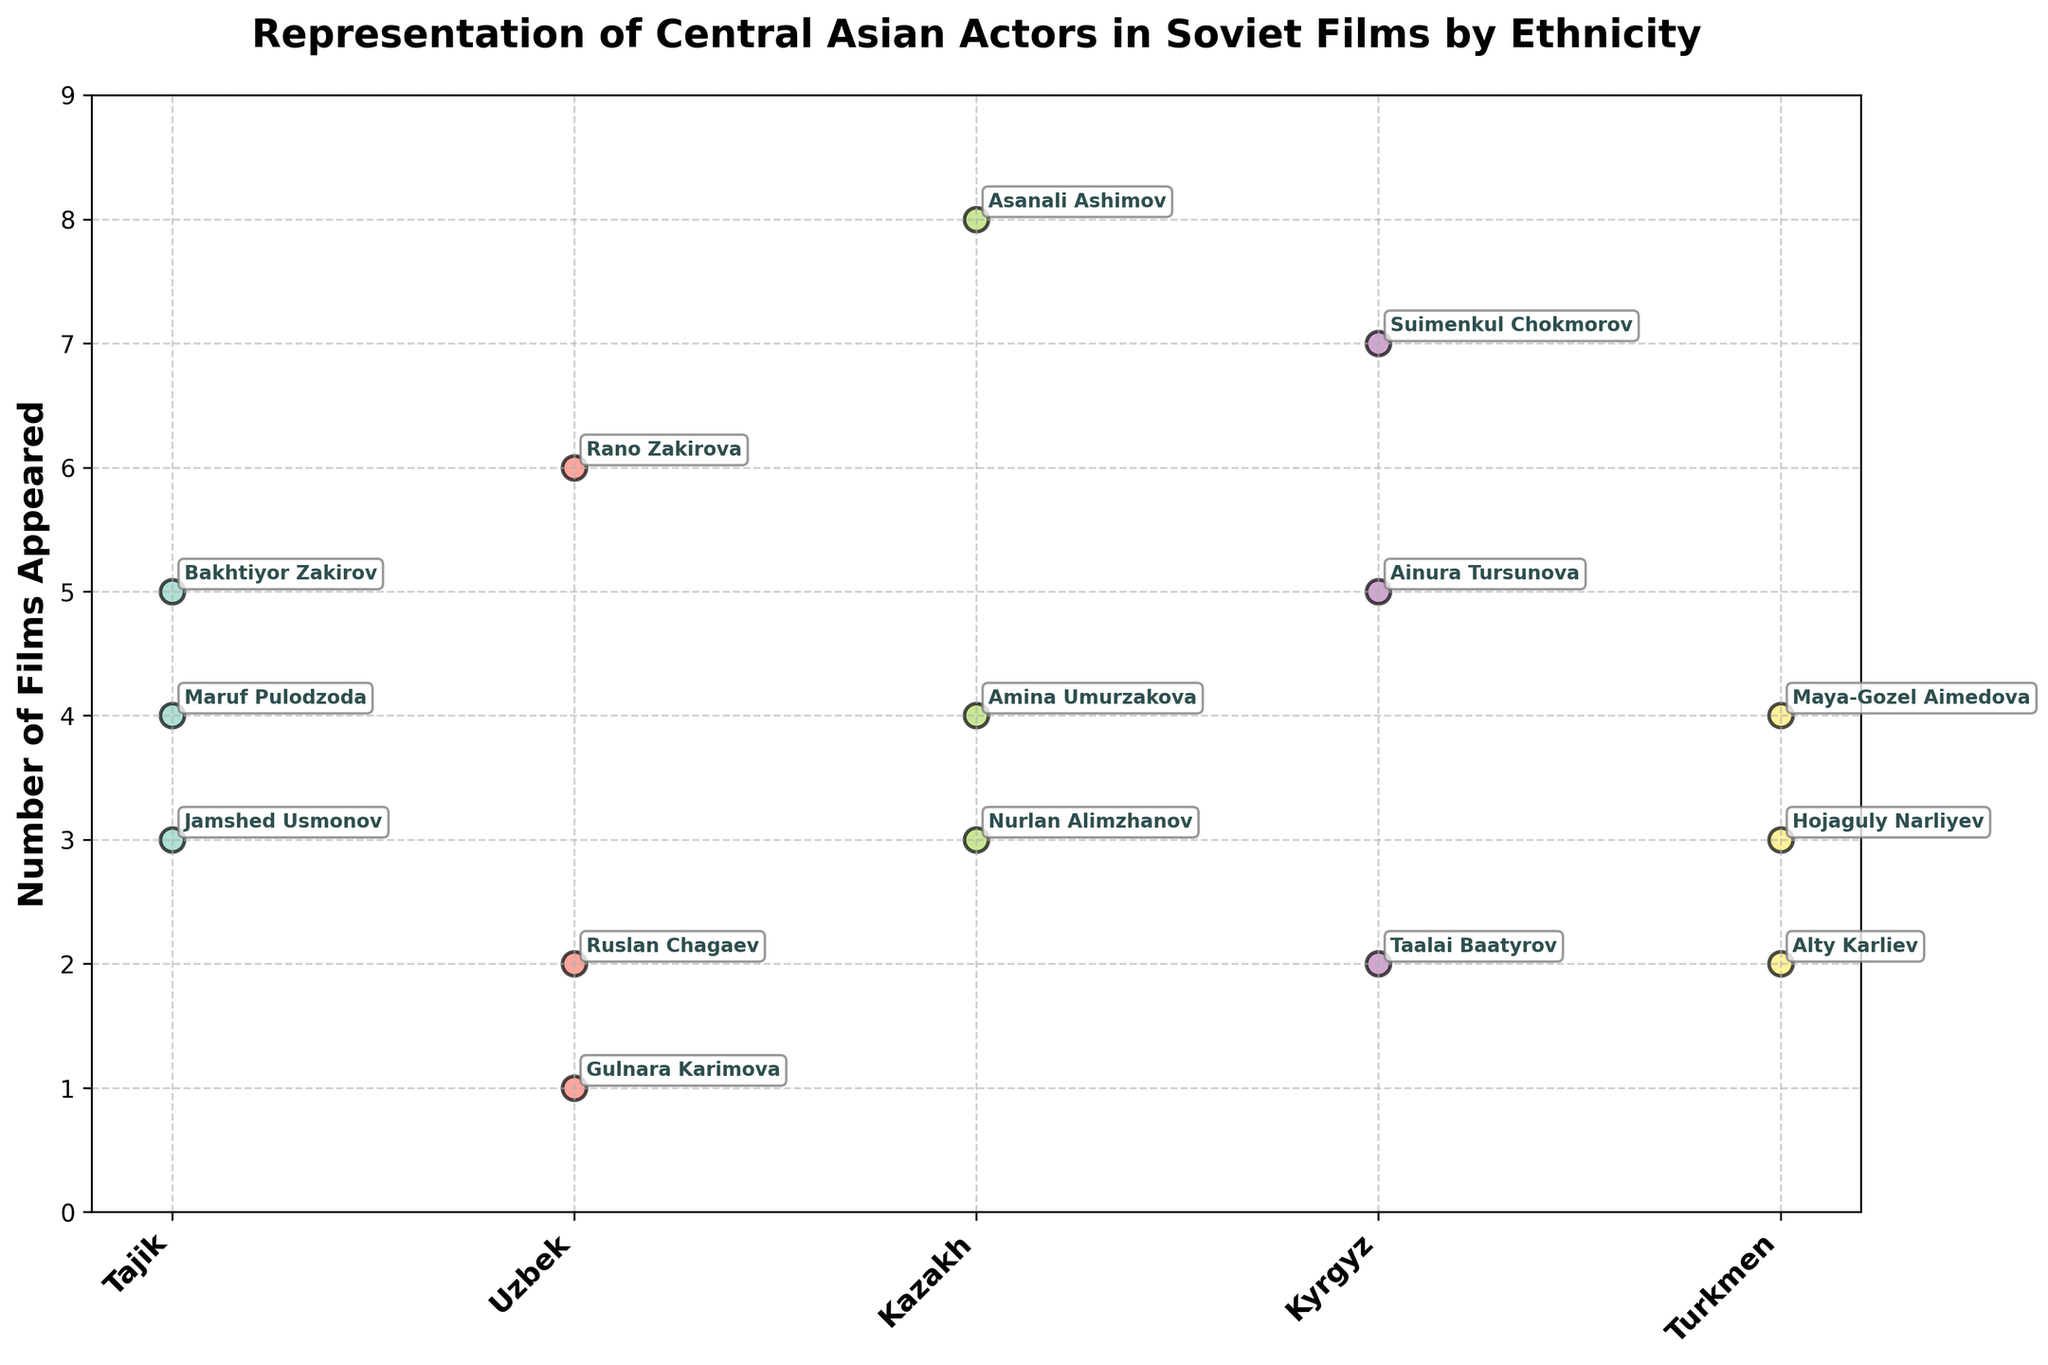Which ethnicity is shown to have the highest number of film appearances? The Kazakh ethnicity has the highest number of film appearances. Asanali Ashimov appears in 8 films, which is the highest count among all actors.
Answer: Kazakh How many films did Gulnara Karimova (Uzbek) appear in? Gulnara Karimova from the Uzbek ethnicity appeared in 1 film, as indicated by the number beside her name on the plot.
Answer: 1 What's the total number of films that actors from the Tajik ethnicity have appeared in? Summing the films appeared for each Tajik actor: Bakhtiyor Zakirov (5) + Jamshed Usmonov (3) + Maruf Pulodzoda (4) equals 12 films in total.
Answer: 12 Which Kazakh actor has appeared in the least number of films? Nurlan Alimzhanov has appeared in the least number of films among Kazakh actors with 3 films.
Answer: Nurlan Alimzhanov How many actors from the Kyrgyz ethnicity have appeared in exactly 5 films? Ainura Tursunova from the Kyrgyz ethnicity has appeared in 5 films, as indicated in the plot.
Answer: 1 Which ethnic group has the widest range in the number of films appeared? The Kyrgyz ethnicity has the widest range, with Suimenkul Chokmorov appearing in 7 films and Taalai Baatyrov in 2 films, a range of 7 - 2 = 5.
Answer: Kyrgyz What's the average number of films appeared by Tajik actors? Sum the films appeared by Tajik actors (5 + 3 + 4 = 12) and divide by the number of actors (3), which gives an average of 12 / 3 = 4.
Answer: 4 Compare the number of films Ruslan Chagaev and Taalai Baatyrov appeared in. Who appeared more? Ruslan Chagaev (Uzbek) appeared in 2 films and Taalai Baatyrov (Kyrgyz) also appeared in 2 films. Both appeared in the same number of films.
Answer: Same What's the title of the plot? The title of the plot, as indicated at the top, is "Representation of Central Asian Actors in Soviet Films by Ethnicity".
Answer: Representation of Central Asian Actors in Soviet Films by Ethnicity Which Turkmen actor has the most film appearances? Maya-Gozel Aimedova from the Turkmen ethnicity has the most film appearances with 4 films.
Answer: Maya-Gozel Aimedova 